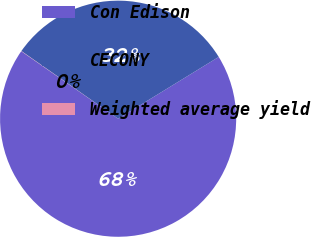<chart> <loc_0><loc_0><loc_500><loc_500><pie_chart><fcel>Con Edison<fcel>CECONY<fcel>Weighted average yield<nl><fcel>68.45%<fcel>31.52%<fcel>0.03%<nl></chart> 